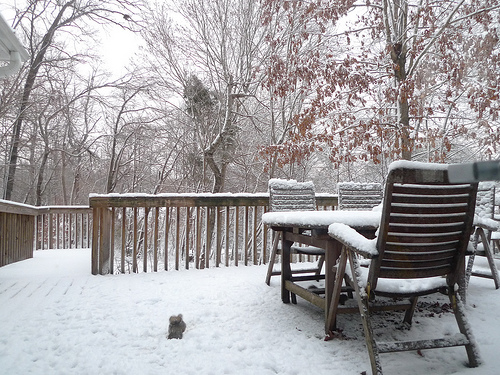<image>
Can you confirm if the railing is behind the railing? Yes. From this viewpoint, the railing is positioned behind the railing, with the railing partially or fully occluding the railing. 